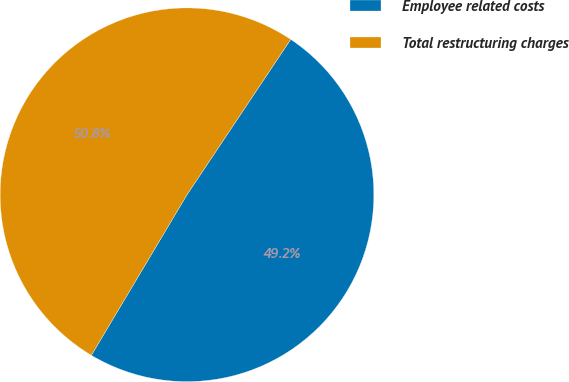Convert chart. <chart><loc_0><loc_0><loc_500><loc_500><pie_chart><fcel>Employee related costs<fcel>Total restructuring charges<nl><fcel>49.18%<fcel>50.82%<nl></chart> 